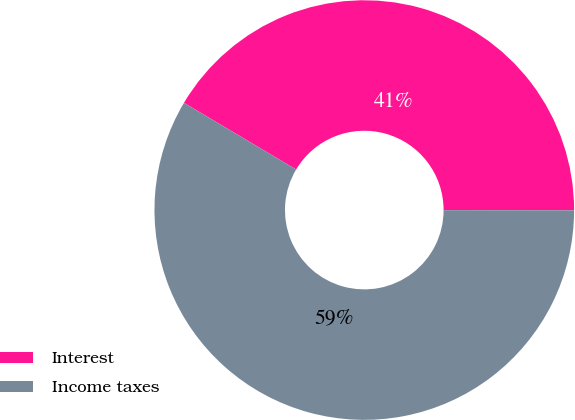Convert chart. <chart><loc_0><loc_0><loc_500><loc_500><pie_chart><fcel>Interest<fcel>Income taxes<nl><fcel>41.48%<fcel>58.52%<nl></chart> 